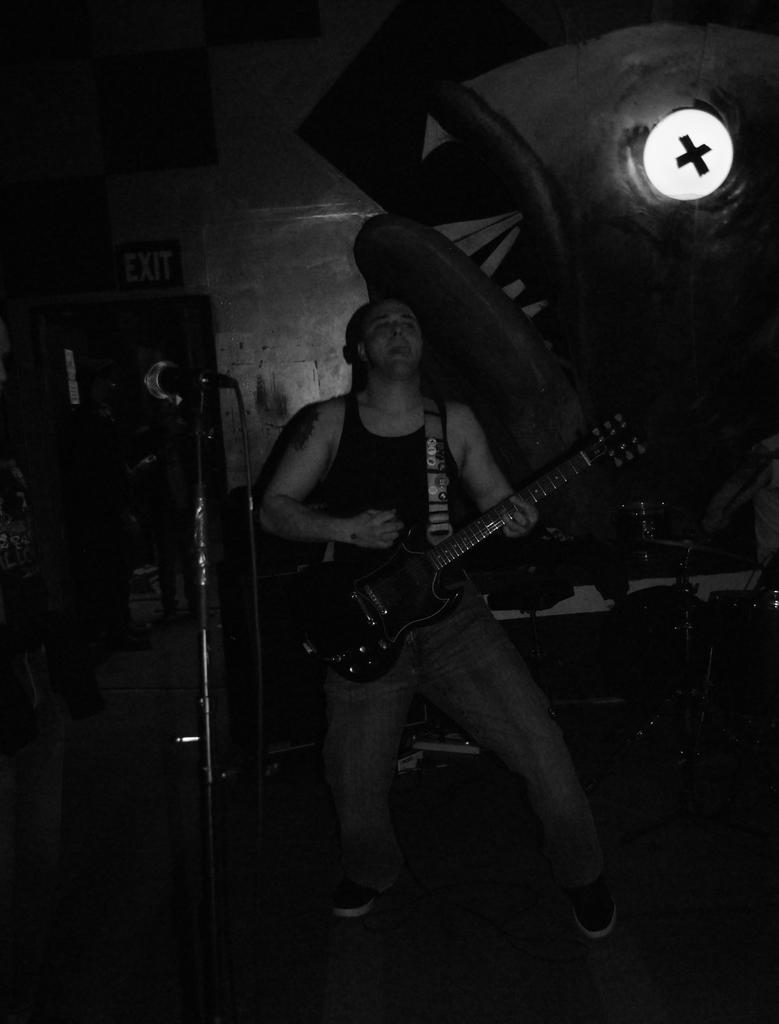What is the main subject of the image? There is a person in the image. What is the person doing in the image? The person is standing and holding a guitar in their hand. What other object can be seen in the image related to the person's activity? There is a microphone with a stand in the image. How is the image presented in terms of color? The image is in black and white color. Where is the hydrant located in the image? There is no hydrant present in the image. What type of meat is being prepared by the person in the image? There is no meat or preparation of meat in the image; the person is holding a guitar and standing near a microphone. 